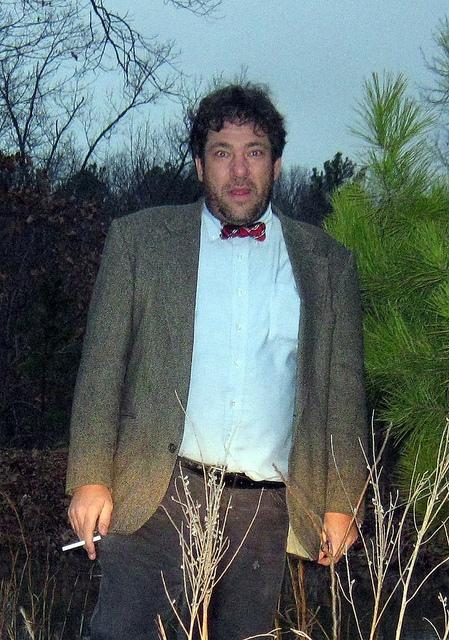Is the man considered attractive, according to current social norms?
Answer briefly. No. Does this man smoke?
Be succinct. Yes. Where is a small, red bow tie?
Write a very short answer. Neck. 